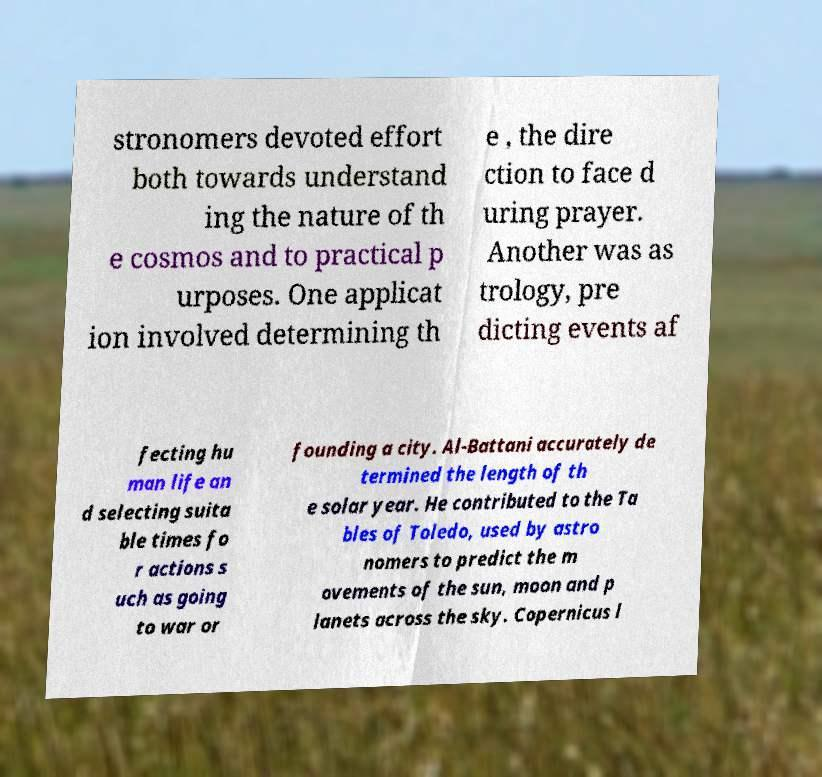I need the written content from this picture converted into text. Can you do that? stronomers devoted effort both towards understand ing the nature of th e cosmos and to practical p urposes. One applicat ion involved determining th e , the dire ction to face d uring prayer. Another was as trology, pre dicting events af fecting hu man life an d selecting suita ble times fo r actions s uch as going to war or founding a city. Al-Battani accurately de termined the length of th e solar year. He contributed to the Ta bles of Toledo, used by astro nomers to predict the m ovements of the sun, moon and p lanets across the sky. Copernicus l 